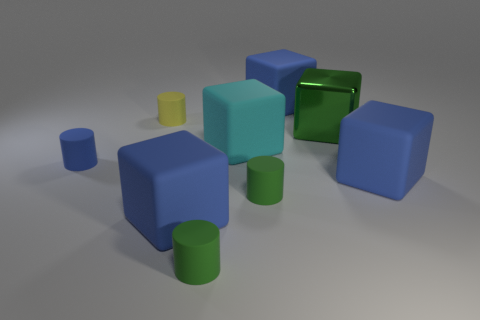What is the size of the matte cylinder that is behind the large green shiny cube?
Your answer should be very brief. Small. Does the green metallic object have the same size as the cylinder behind the tiny blue rubber thing?
Provide a succinct answer. No. There is a big block behind the tiny object behind the large green block; what is its color?
Your answer should be compact. Blue. What number of other things are the same color as the metal cube?
Your answer should be compact. 2. The cyan matte block has what size?
Your response must be concise. Large. Are there more small green rubber cylinders to the left of the small blue rubber thing than blue blocks that are left of the big cyan rubber object?
Ensure brevity in your answer.  No. There is a thing behind the yellow rubber cylinder; what number of large metallic things are behind it?
Your response must be concise. 0. There is a green object behind the small blue object; does it have the same shape as the cyan rubber thing?
Your answer should be compact. Yes. There is a blue object that is the same shape as the yellow object; what is its material?
Ensure brevity in your answer.  Rubber. How many blue blocks are the same size as the cyan rubber object?
Provide a succinct answer. 3. 